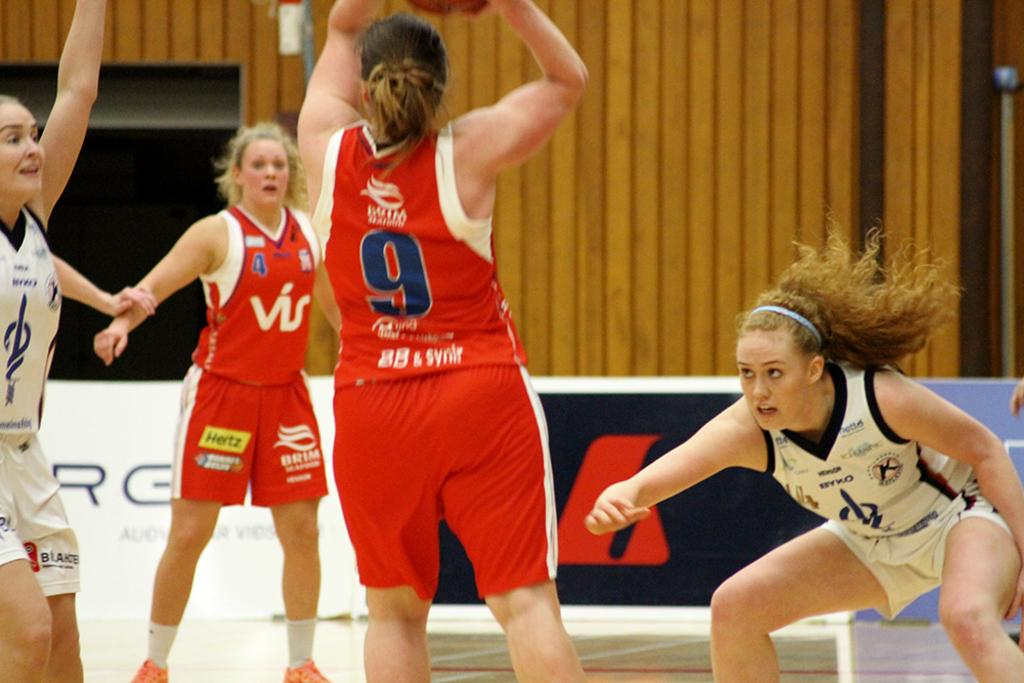<image>
Describe the image concisely. number 9 in red shoots the ball  while players in white wearing a k patch defend 